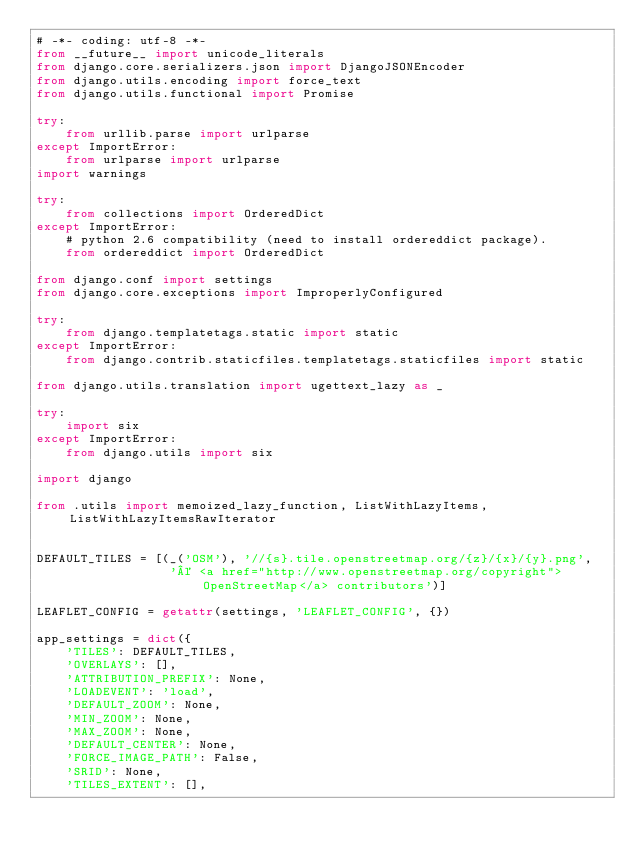Convert code to text. <code><loc_0><loc_0><loc_500><loc_500><_Python_># -*- coding: utf-8 -*-
from __future__ import unicode_literals
from django.core.serializers.json import DjangoJSONEncoder
from django.utils.encoding import force_text
from django.utils.functional import Promise

try:
    from urllib.parse import urlparse
except ImportError:
    from urlparse import urlparse
import warnings

try:
    from collections import OrderedDict
except ImportError:
    # python 2.6 compatibility (need to install ordereddict package).
    from ordereddict import OrderedDict

from django.conf import settings
from django.core.exceptions import ImproperlyConfigured

try:
    from django.templatetags.static import static
except ImportError:
    from django.contrib.staticfiles.templatetags.staticfiles import static

from django.utils.translation import ugettext_lazy as _

try:
    import six
except ImportError:
    from django.utils import six

import django

from .utils import memoized_lazy_function, ListWithLazyItems, ListWithLazyItemsRawIterator


DEFAULT_TILES = [(_('OSM'), '//{s}.tile.openstreetmap.org/{z}/{x}/{y}.png',
                  '© <a href="http://www.openstreetmap.org/copyright">OpenStreetMap</a> contributors')]

LEAFLET_CONFIG = getattr(settings, 'LEAFLET_CONFIG', {})

app_settings = dict({
    'TILES': DEFAULT_TILES,
    'OVERLAYS': [],
    'ATTRIBUTION_PREFIX': None,
    'LOADEVENT': 'load',
    'DEFAULT_ZOOM': None,
    'MIN_ZOOM': None,
    'MAX_ZOOM': None,
    'DEFAULT_CENTER': None,
    'FORCE_IMAGE_PATH': False,
    'SRID': None,
    'TILES_EXTENT': [],</code> 